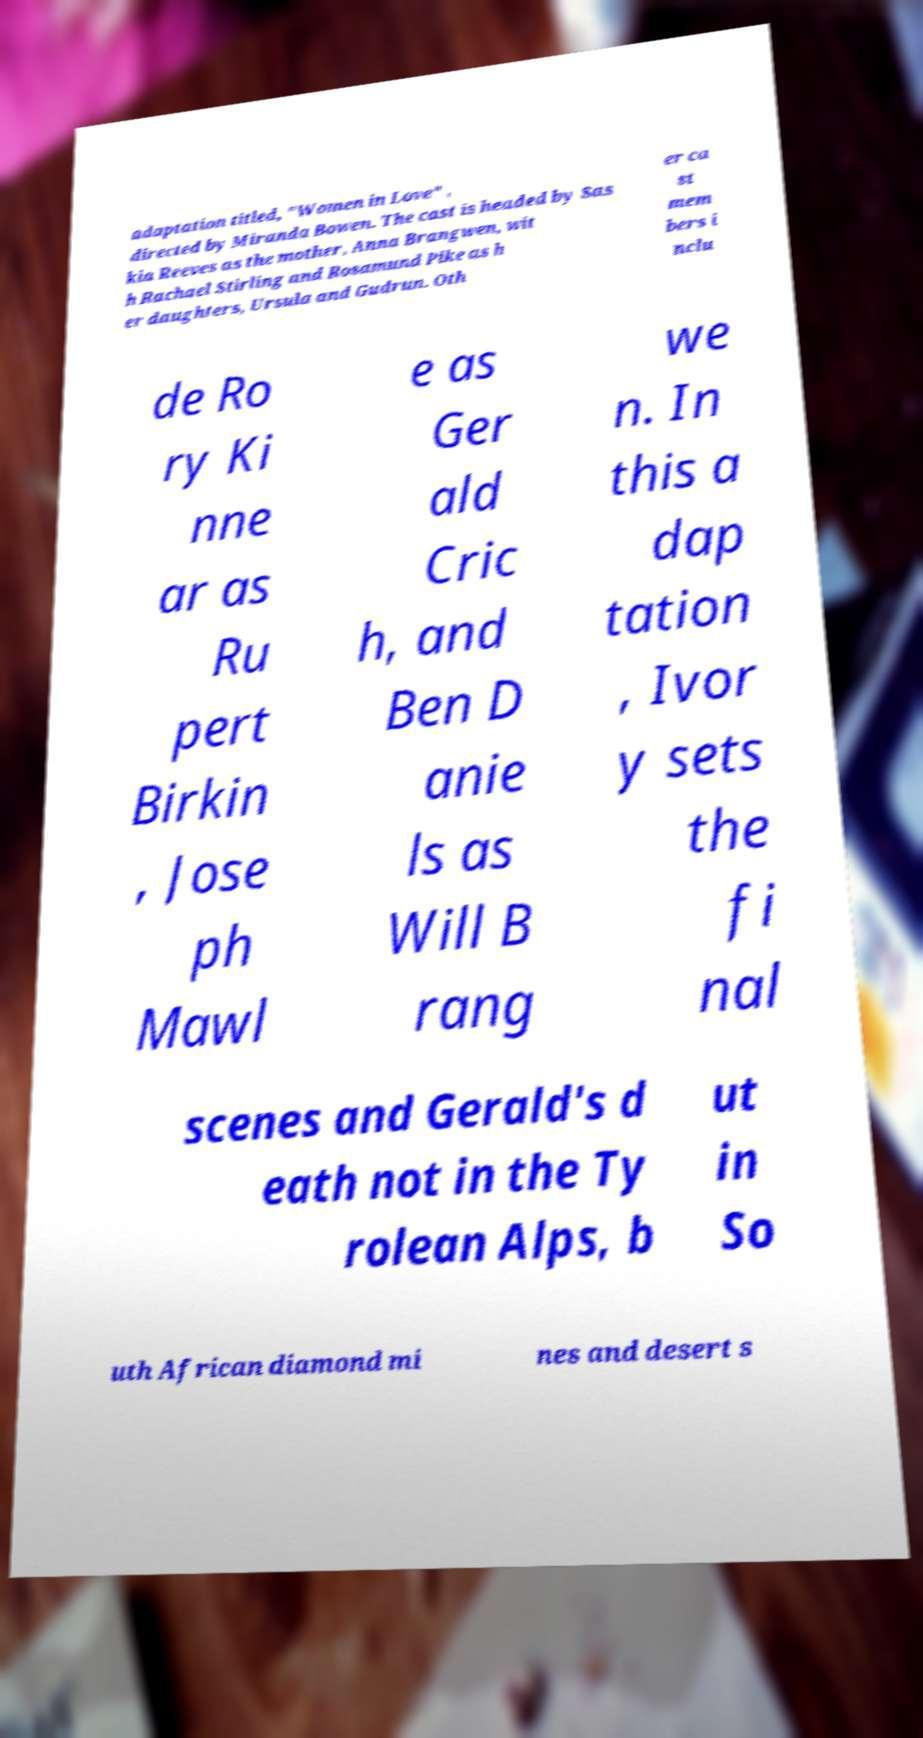Could you assist in decoding the text presented in this image and type it out clearly? adaptation titled, "Women in Love" , directed by Miranda Bowen. The cast is headed by Sas kia Reeves as the mother, Anna Brangwen, wit h Rachael Stirling and Rosamund Pike as h er daughters, Ursula and Gudrun. Oth er ca st mem bers i nclu de Ro ry Ki nne ar as Ru pert Birkin , Jose ph Mawl e as Ger ald Cric h, and Ben D anie ls as Will B rang we n. In this a dap tation , Ivor y sets the fi nal scenes and Gerald's d eath not in the Ty rolean Alps, b ut in So uth African diamond mi nes and desert s 